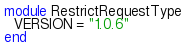Convert code to text. <code><loc_0><loc_0><loc_500><loc_500><_Ruby_>module RestrictRequestType
  VERSION = "1.0.6"
end
</code> 